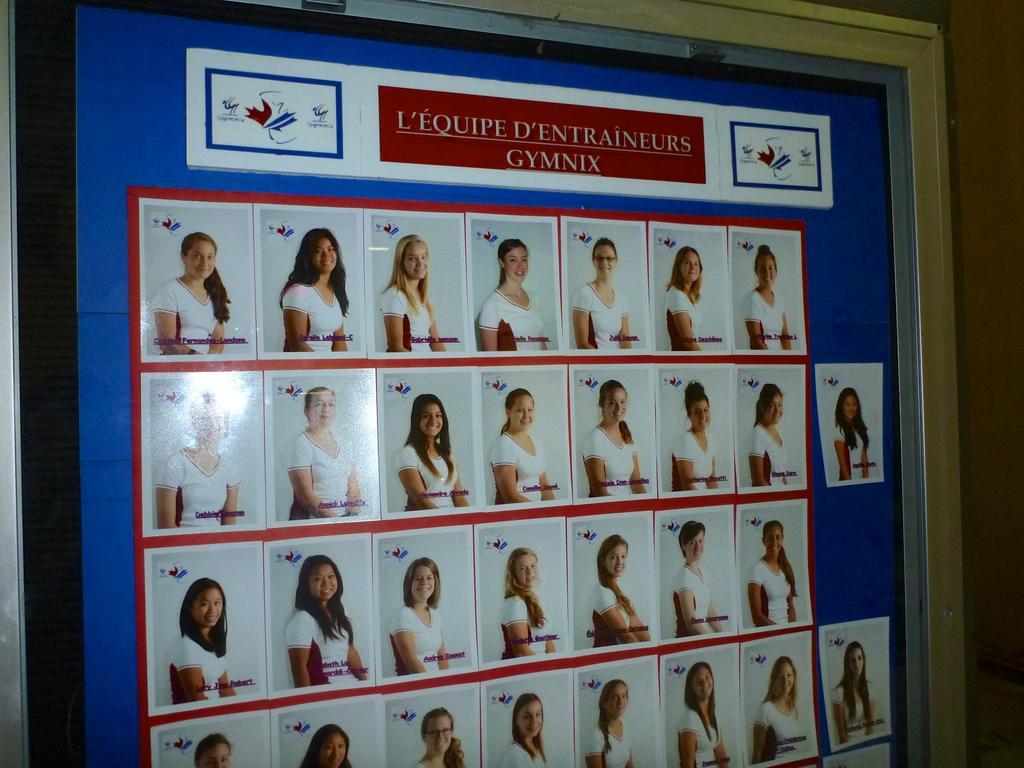Describe this image in one or two sentences. In the picture I can see a board which has photos attached to it. In this photo I can see women who are wearing white color clothes and smiling. 